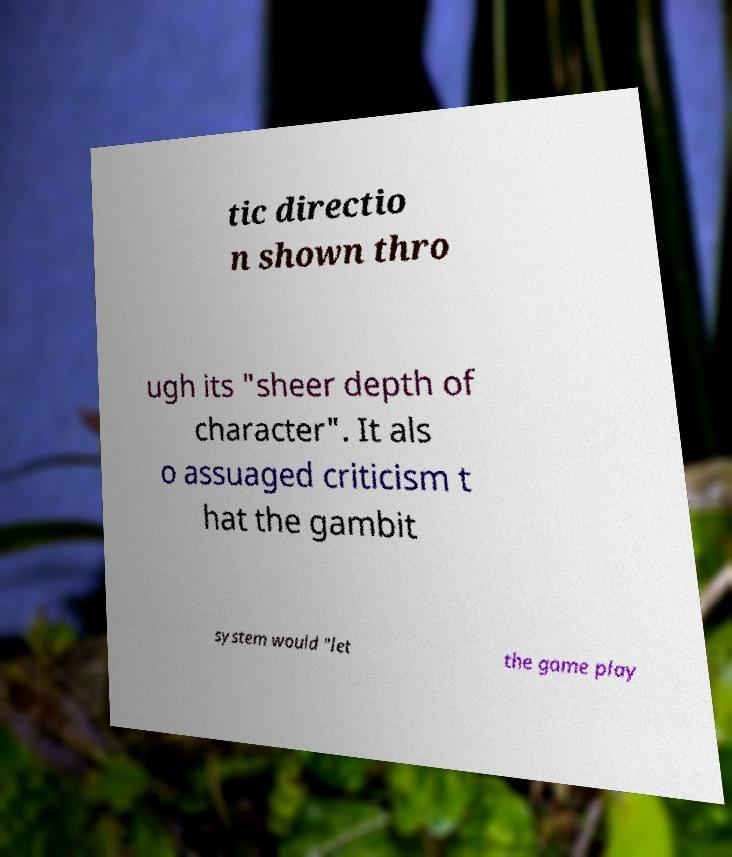Can you read and provide the text displayed in the image?This photo seems to have some interesting text. Can you extract and type it out for me? tic directio n shown thro ugh its "sheer depth of character". It als o assuaged criticism t hat the gambit system would "let the game play 